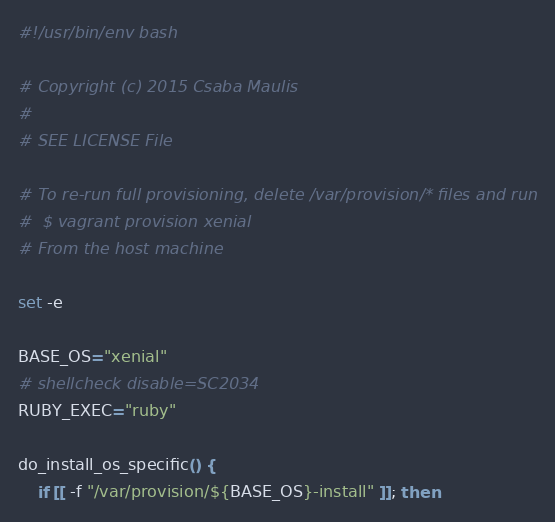<code> <loc_0><loc_0><loc_500><loc_500><_Bash_>#!/usr/bin/env bash

# Copyright (c) 2015 Csaba Maulis
#
# SEE LICENSE File

# To re-run full provisioning, delete /var/provision/* files and run
#  $ vagrant provision xenial
# From the host machine

set -e

BASE_OS="xenial"
# shellcheck disable=SC2034
RUBY_EXEC="ruby"

do_install_os_specific() {
    if [[ -f "/var/provision/${BASE_OS}-install" ]]; then</code> 